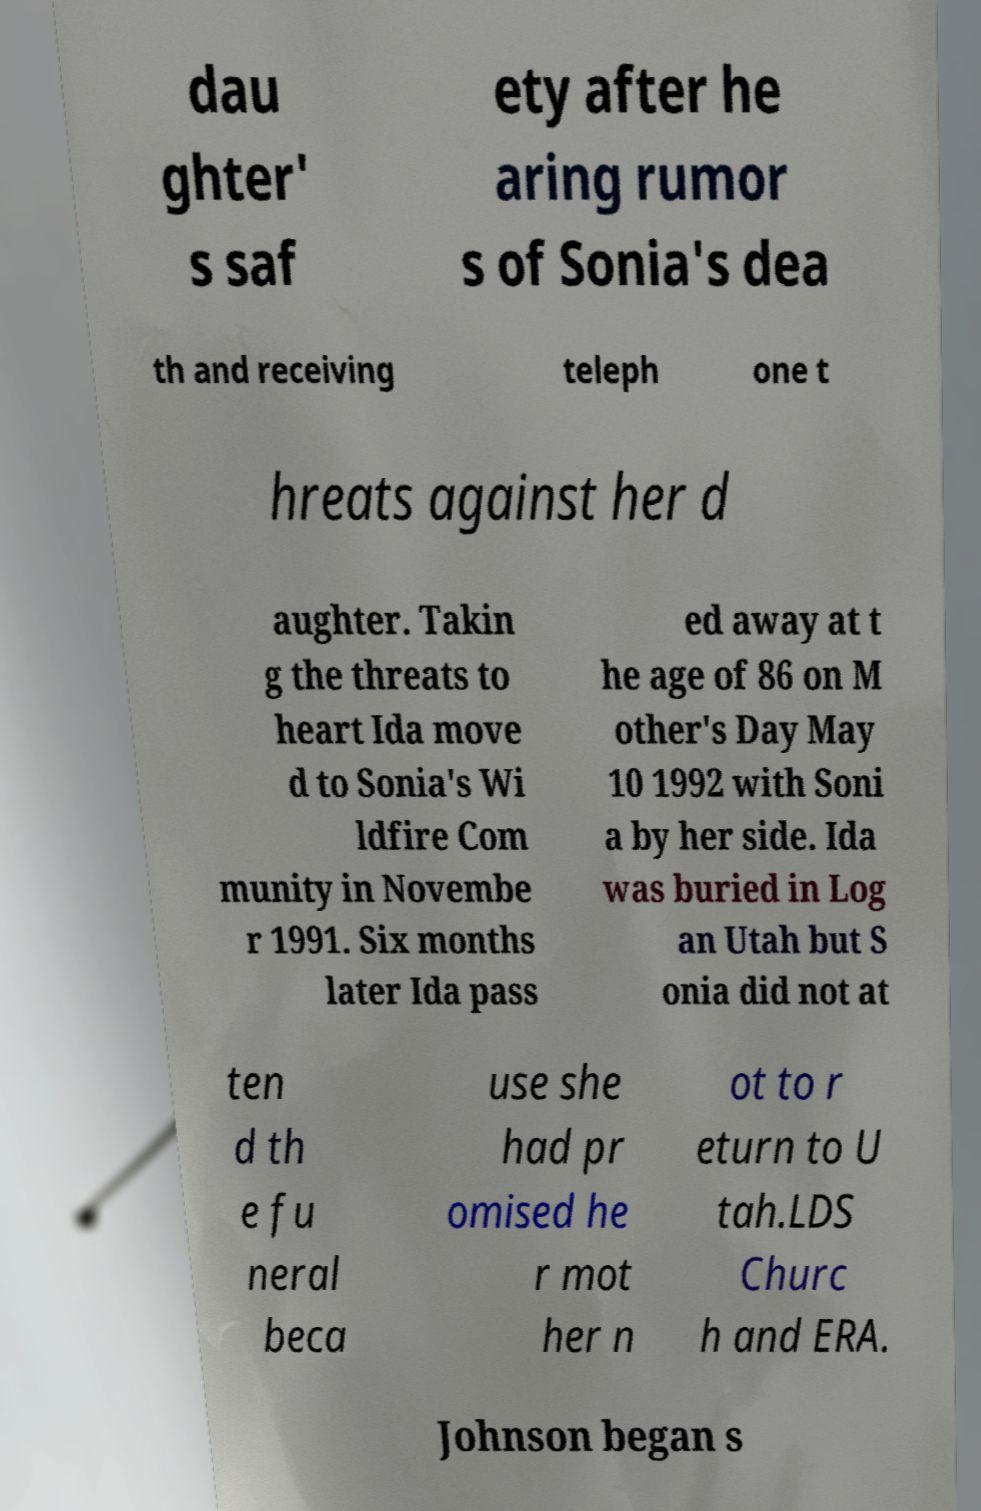There's text embedded in this image that I need extracted. Can you transcribe it verbatim? dau ghter' s saf ety after he aring rumor s of Sonia's dea th and receiving teleph one t hreats against her d aughter. Takin g the threats to heart Ida move d to Sonia's Wi ldfire Com munity in Novembe r 1991. Six months later Ida pass ed away at t he age of 86 on M other's Day May 10 1992 with Soni a by her side. Ida was buried in Log an Utah but S onia did not at ten d th e fu neral beca use she had pr omised he r mot her n ot to r eturn to U tah.LDS Churc h and ERA. Johnson began s 